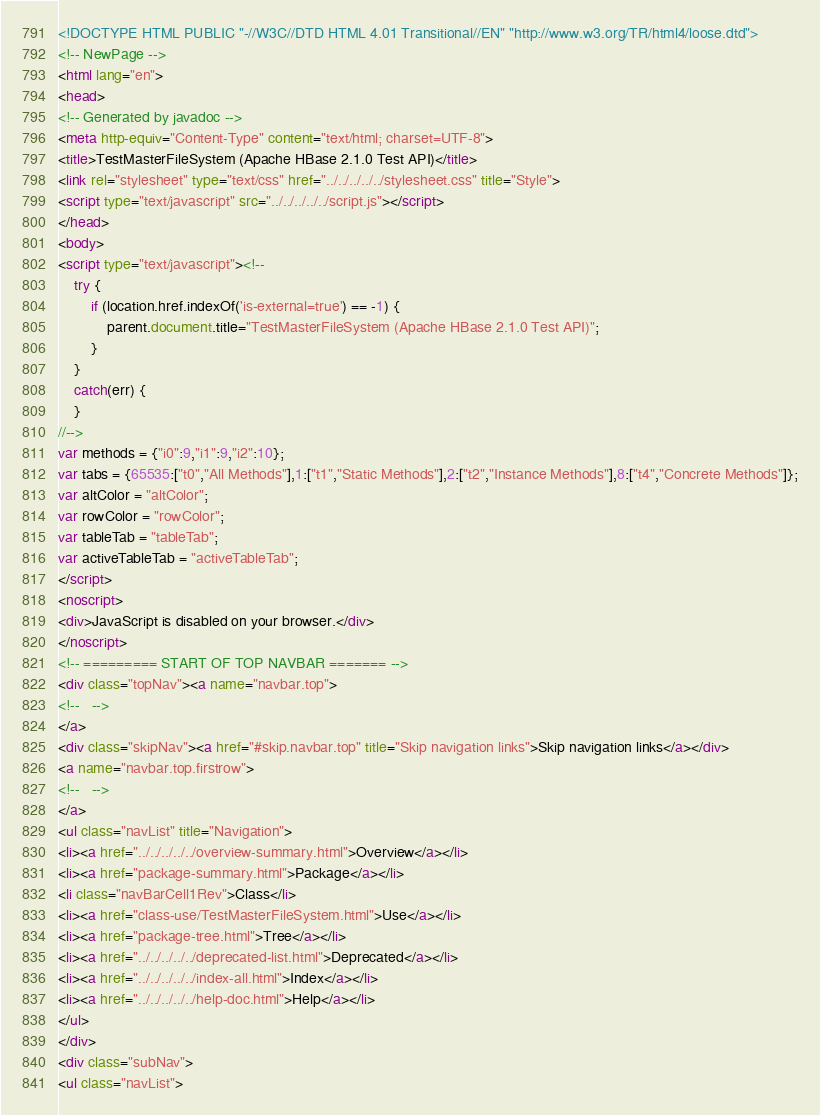Convert code to text. <code><loc_0><loc_0><loc_500><loc_500><_HTML_><!DOCTYPE HTML PUBLIC "-//W3C//DTD HTML 4.01 Transitional//EN" "http://www.w3.org/TR/html4/loose.dtd">
<!-- NewPage -->
<html lang="en">
<head>
<!-- Generated by javadoc -->
<meta http-equiv="Content-Type" content="text/html; charset=UTF-8">
<title>TestMasterFileSystem (Apache HBase 2.1.0 Test API)</title>
<link rel="stylesheet" type="text/css" href="../../../../../stylesheet.css" title="Style">
<script type="text/javascript" src="../../../../../script.js"></script>
</head>
<body>
<script type="text/javascript"><!--
    try {
        if (location.href.indexOf('is-external=true') == -1) {
            parent.document.title="TestMasterFileSystem (Apache HBase 2.1.0 Test API)";
        }
    }
    catch(err) {
    }
//-->
var methods = {"i0":9,"i1":9,"i2":10};
var tabs = {65535:["t0","All Methods"],1:["t1","Static Methods"],2:["t2","Instance Methods"],8:["t4","Concrete Methods"]};
var altColor = "altColor";
var rowColor = "rowColor";
var tableTab = "tableTab";
var activeTableTab = "activeTableTab";
</script>
<noscript>
<div>JavaScript is disabled on your browser.</div>
</noscript>
<!-- ========= START OF TOP NAVBAR ======= -->
<div class="topNav"><a name="navbar.top">
<!--   -->
</a>
<div class="skipNav"><a href="#skip.navbar.top" title="Skip navigation links">Skip navigation links</a></div>
<a name="navbar.top.firstrow">
<!--   -->
</a>
<ul class="navList" title="Navigation">
<li><a href="../../../../../overview-summary.html">Overview</a></li>
<li><a href="package-summary.html">Package</a></li>
<li class="navBarCell1Rev">Class</li>
<li><a href="class-use/TestMasterFileSystem.html">Use</a></li>
<li><a href="package-tree.html">Tree</a></li>
<li><a href="../../../../../deprecated-list.html">Deprecated</a></li>
<li><a href="../../../../../index-all.html">Index</a></li>
<li><a href="../../../../../help-doc.html">Help</a></li>
</ul>
</div>
<div class="subNav">
<ul class="navList"></code> 